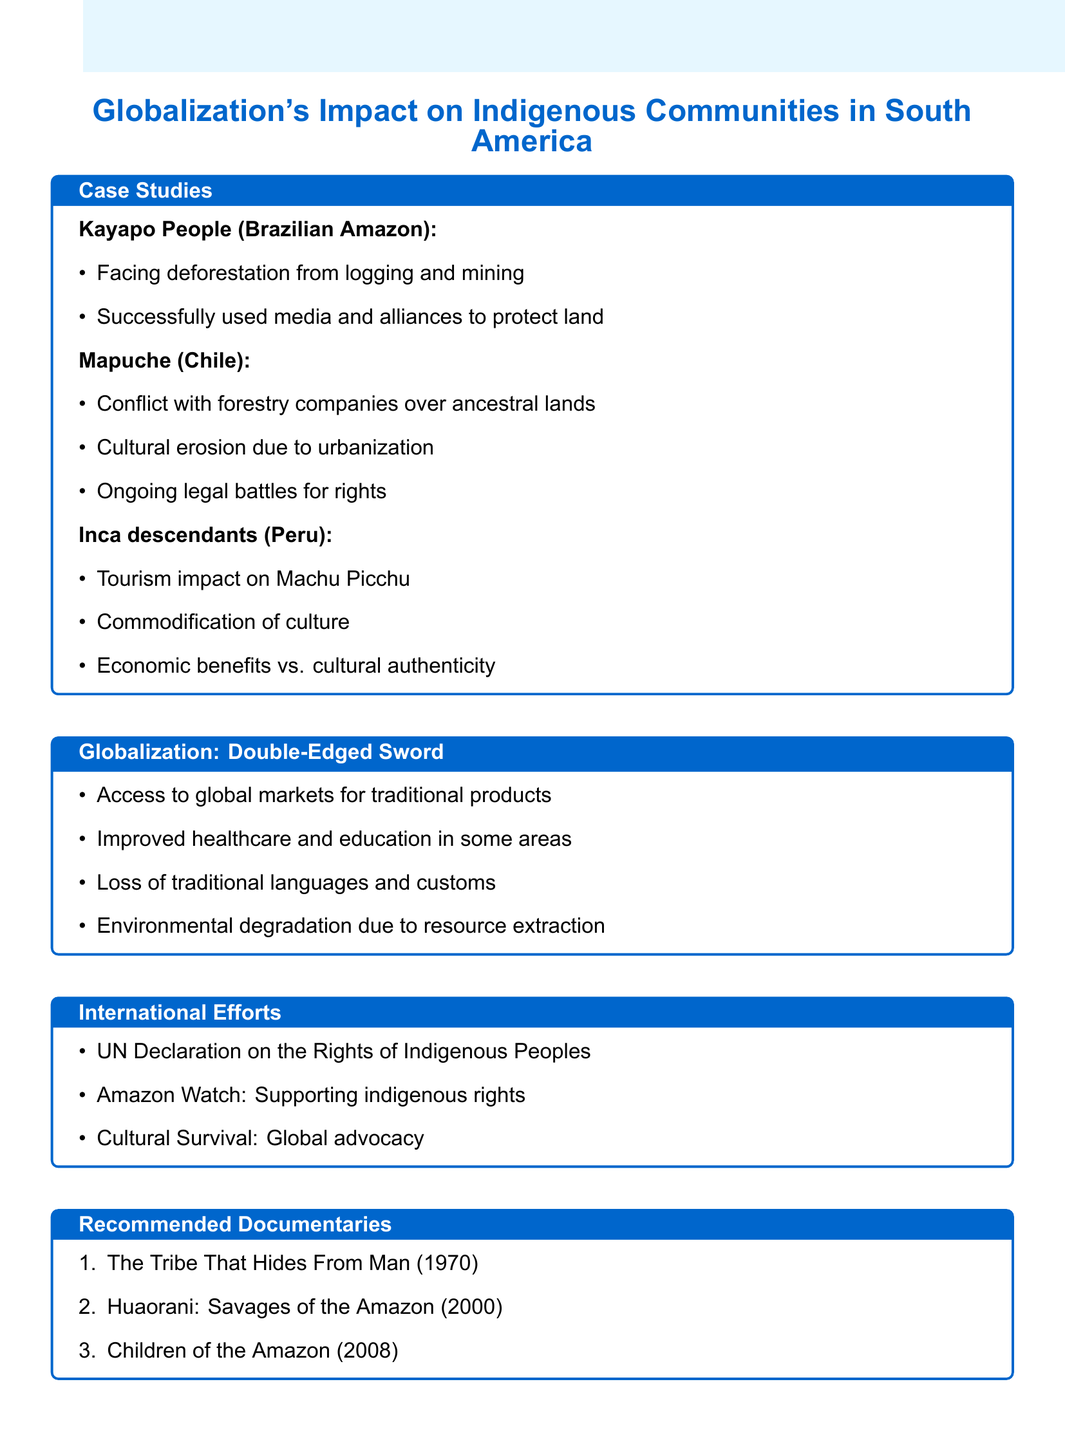What is the location of the Kayapo people? The document specifies that the Kayapo people are located in the Brazilian Amazon.
Answer: Brazilian Amazon What is one impact of globalization on the Mapuche community? The document mentions cultural erosion due to urbanization and modernization as an impact of globalization on the Mapuche community.
Answer: Cultural erosion What are the economic benefits discussed regarding Inca descendants? The document presents the economic benefits versus cultural authenticity dilemma related to tourism around Machu Picchu and surrounding communities.
Answer: Economic benefits Which international organization is mentioned that supports indigenous rights? The document lists Amazon Watch as an NGO that supports indigenous rights.
Answer: Amazon Watch What is a positive aspect of globalization outlined in the document? The document points out improved healthcare and education in some communities as a positive aspect of globalization.
Answer: Improved healthcare and education 